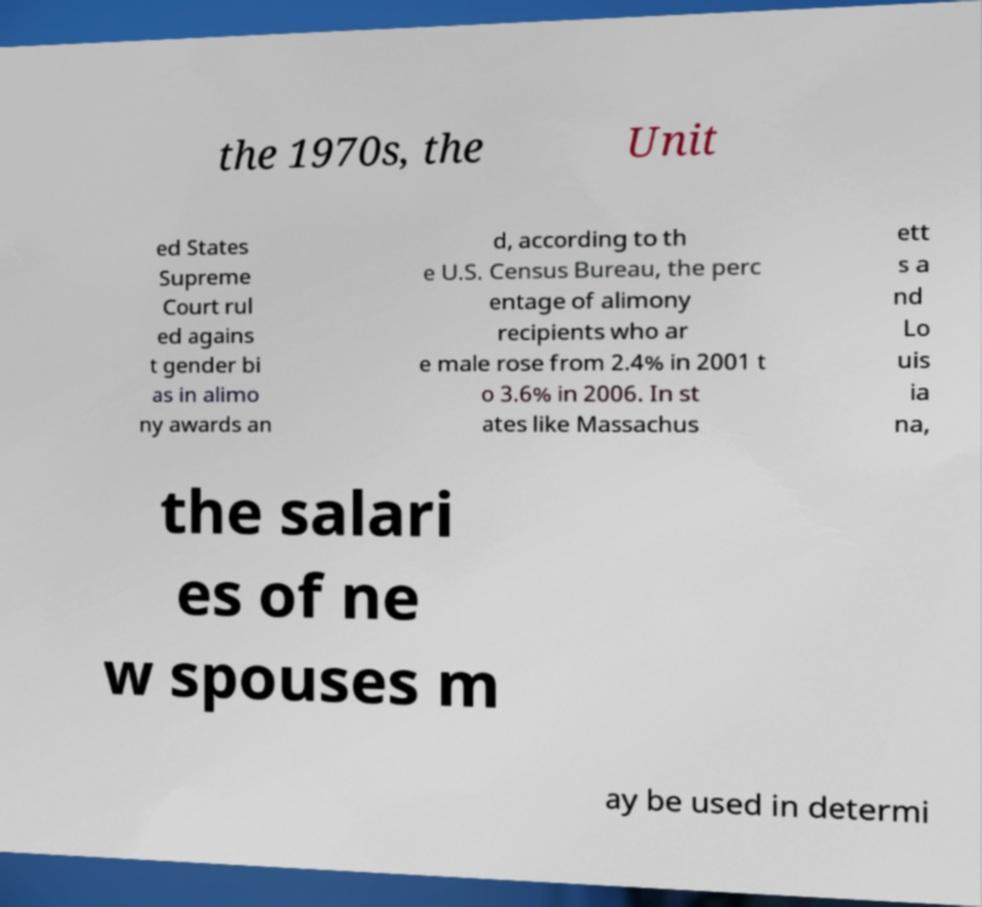Can you accurately transcribe the text from the provided image for me? the 1970s, the Unit ed States Supreme Court rul ed agains t gender bi as in alimo ny awards an d, according to th e U.S. Census Bureau, the perc entage of alimony recipients who ar e male rose from 2.4% in 2001 t o 3.6% in 2006. In st ates like Massachus ett s a nd Lo uis ia na, the salari es of ne w spouses m ay be used in determi 